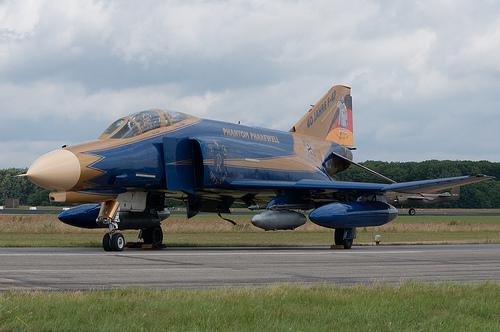Combine the main object with the surrounding background elements to form a descriptive sentence. The blue and gold fighter jet stands boldly on the tarmac, embracing the vibrant blue sky peppered with white clouds and the green grass encircling it. Create an object-focused description using sensory words about the primary object and its environment. The blue and gold fighter jet sits majestically on the sunlit runway, enveloped by the aroma of fresh green grass and the soothing sights of fluffy white clouds in the azure heavens. Describe the visual experience of observing the main object and the background elements. When glancing at the image, you see a stunning blue and yellow military jet on a clear runway, surrounded by vivid green grass, white clouds, and lovely blue skies above. Provide a brief yet detailed description of the primary object and its immediate environment. The large blue and gold fighter jet has a white nose section, black wheels, cockpit window, and an engine under its wing, all set against a backdrop featuring blue skies, and green grass below. Write a brief and simple description of the prominent object and its surroundings in the image. A blue and gold fighter jet is on the runway, with white clouds in the blue sky behind it and green grass around it. Write a short creative story inspired by the main object and the scenery in the image. Once upon a time in a remote airbase, a blue and gold fighter jet stood proudly on the runway, ready for its next mission, as the white clouds danced amid the beautiful blue sky above. Form a narrative sentence that conveys the idea of what the main object might be doing, incorporating the background elements. As the blue and gold fighter jet awaits its next assignment on the neatly maintained runway, the puffy white clouds pass overhead, whispering secrets to the green grass below. Summarize the image in a single sentence, focusing on the most noticeable elements. A fighter jet with blue and gold colors is positioned on the tarmac with white clouds in the sky and lush green grass nearby. Explain the setting of the image by mentioning the main object and the environment around it. The image captures a military airplane on a runway, surrounded by green grass and trees, with clusters of white clouds scattered in the blue sky. Describe any important details and features of the main object in the image. The prominent object is a blue and yellow fighter jet with a tan nose, a blue engine under its wing, black wheels, and an open door. 